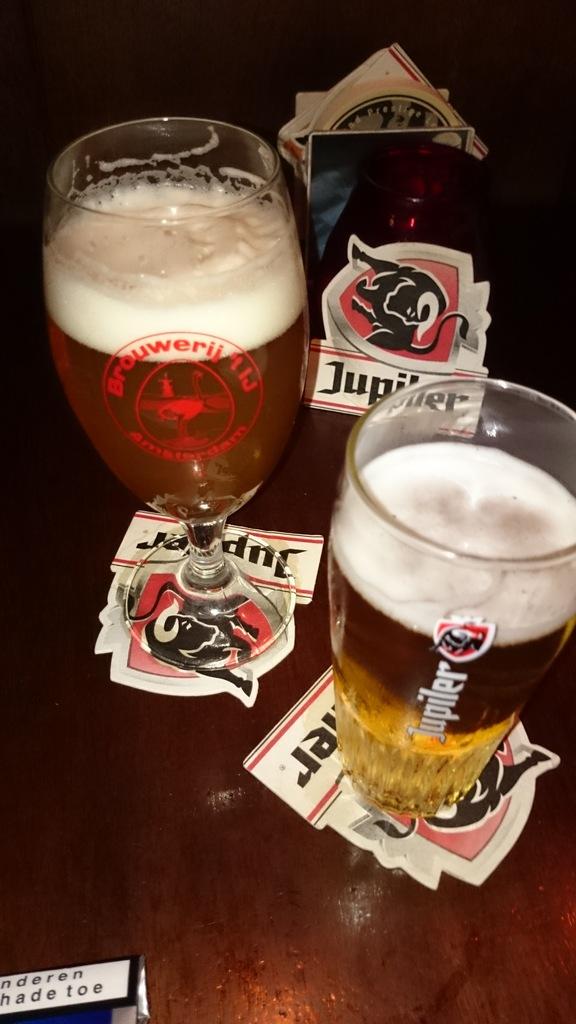What brand is on the drink coasters?
Your answer should be compact. Jupiter. 